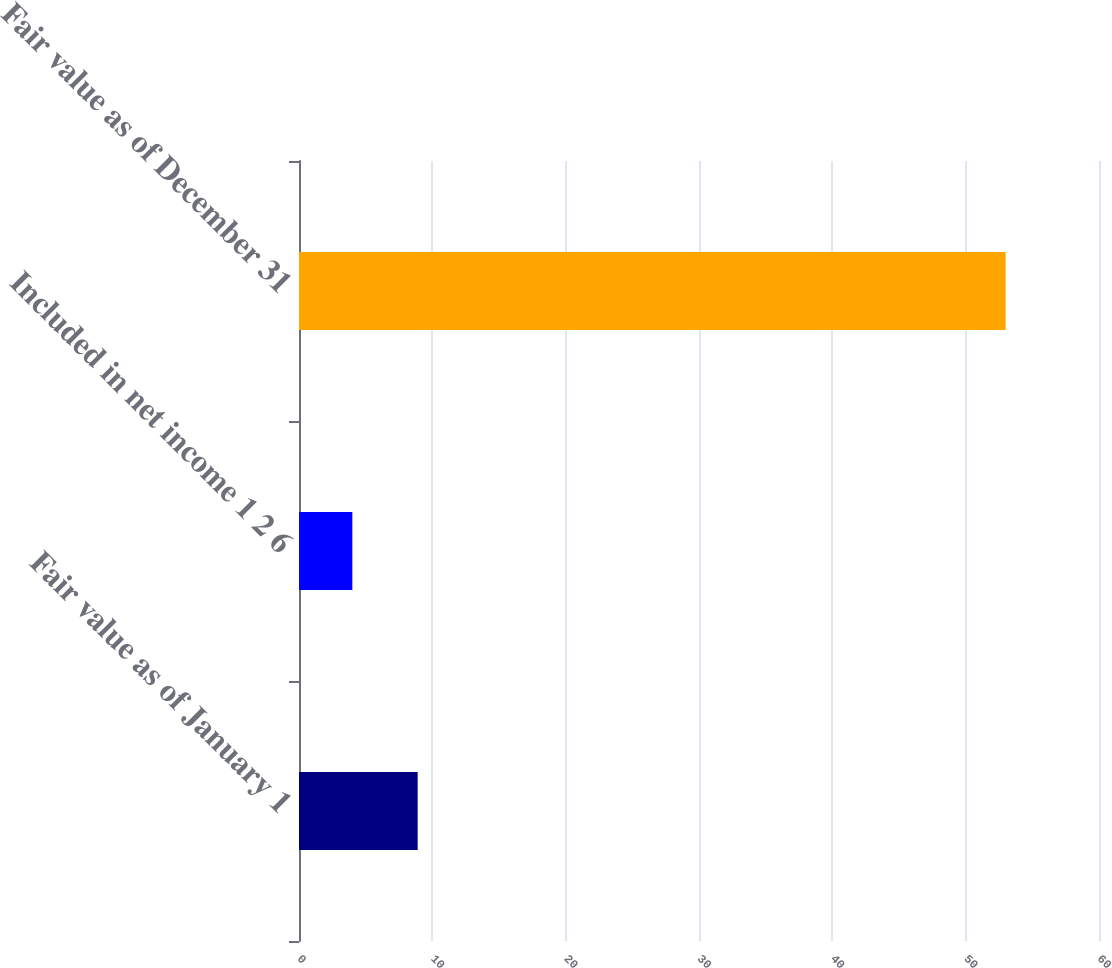Convert chart to OTSL. <chart><loc_0><loc_0><loc_500><loc_500><bar_chart><fcel>Fair value as of January 1<fcel>Included in net income 1 2 6<fcel>Fair value as of December 31<nl><fcel>8.9<fcel>4<fcel>53<nl></chart> 